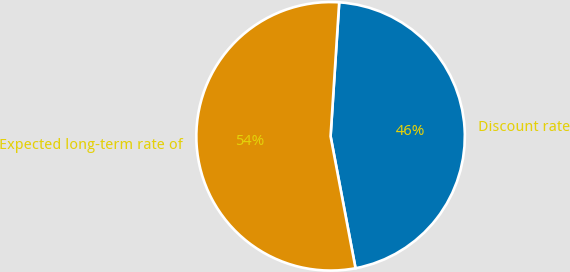<chart> <loc_0><loc_0><loc_500><loc_500><pie_chart><fcel>Discount rate<fcel>Expected long-term rate of<nl><fcel>46.0%<fcel>54.0%<nl></chart> 